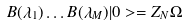Convert formula to latex. <formula><loc_0><loc_0><loc_500><loc_500>B ( \lambda _ { 1 } ) \dots B ( \lambda _ { M } ) | 0 > = Z _ { N } \Omega</formula> 